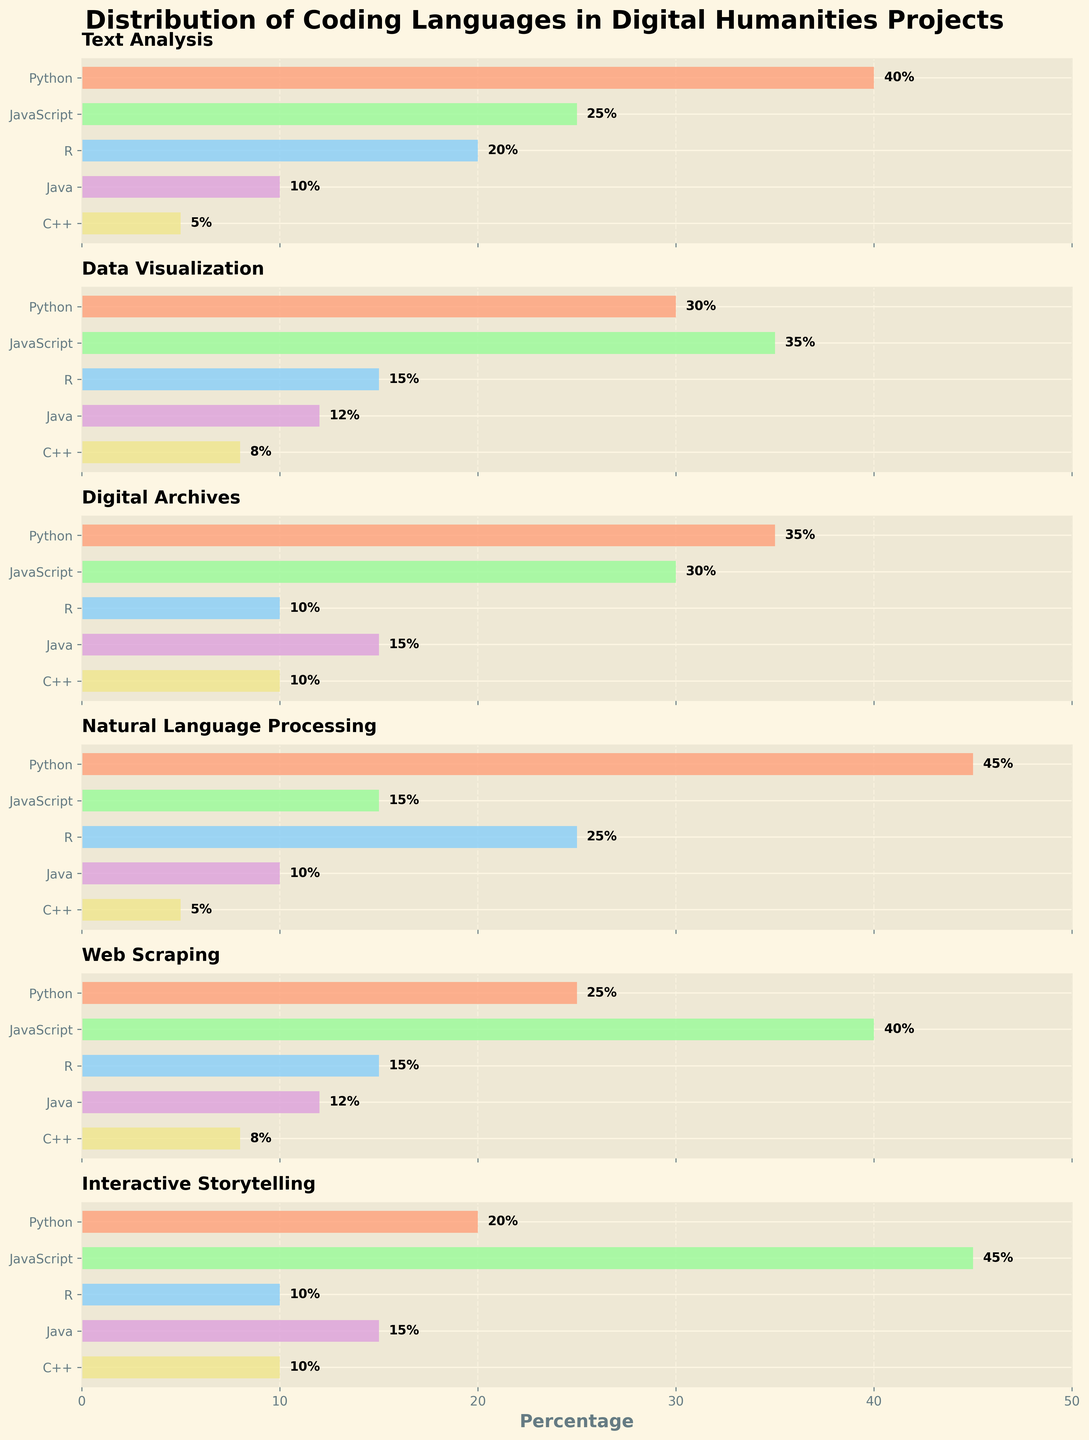What is the title of the figure? The title is displayed at the top of the figure in bold, large font and reads "Distribution of Coding Languages in Digital Humanities Projects".
Answer: Distribution of Coding Languages in Digital Humanities Projects What application uses the most Python? By examining the bars for Python in each subplot, the longest bar is for Natural Language Processing.
Answer: Natural Language Processing What is the percentage of R used in Digital Archives? In the Digital Archives subplot, the bar corresponding to R is labeled with the percentage value.
Answer: 10% Which language is least used in Interactive Storytelling? In the Interactive Storytelling subplot, the shortest bar represents the least used language, which is R.
Answer: R Which application uses JavaScript the most? Comparing the lengths of the bars for JavaScript across all subplots, the longest bar is in the Interactive Storytelling subplot.
Answer: Interactive Storytelling Which coding language is used the least overall across all applications? Sum the values for each language across all applications, and find the language with the lowest total. C++: 5+8+10+5+8+10 = 46, R: 20+15+10+25+15+10 = 95, Java: 10+12+15+10+12+15 = 74, JavaScript: 25+35+30+15+40+45 = 190, Python: 40+30+35+45+25+20 = 195.
Answer: C++ Between Web Scraping and Data Visualization, which application uses more Java? Compare the Java bars in the Web Scraping and Data Visualization subplots, where Web Scraping has 12 and Data Visualization has 12 as well.
Answer: Equal How does the use of Python in Text Analysis compare to its use in Web Scraping? The Python bar for Text Analysis is 40, while for Web Scraping it is 25. 40 - 25 = 15.
Answer: 15% more in Text Analysis What’s the most common language in Data Visualization aside from JavaScript? In the Data Visualization subplot, aside from the tallest JavaScript bar at 35%, the next tallest bar represents Python at 30%.
Answer: Python 